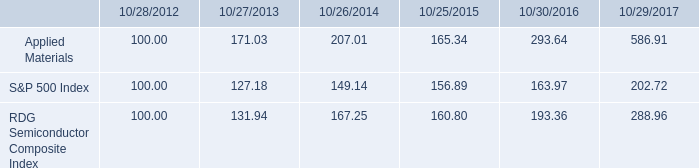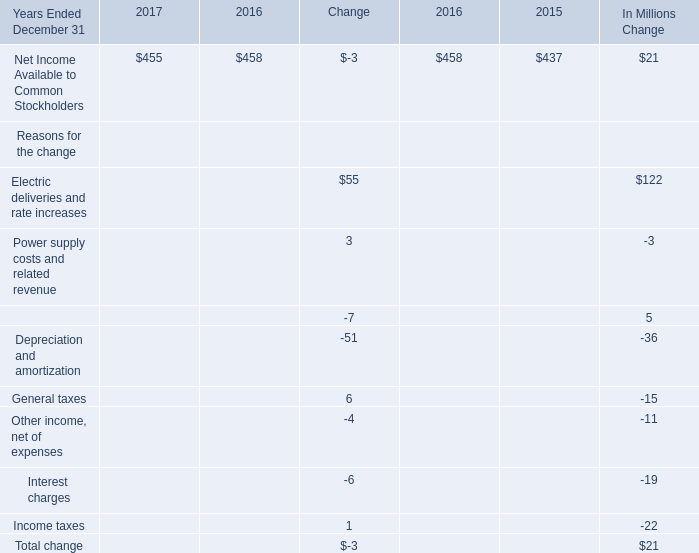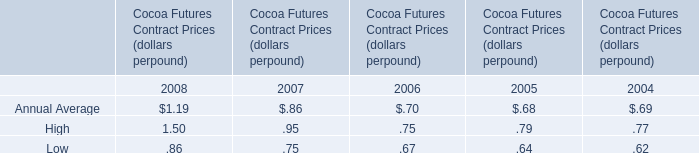What's the growth rate of Net Income Available to Common Stockholders in 2017? 
Computations: (-3 / 458)
Answer: -0.00655. 